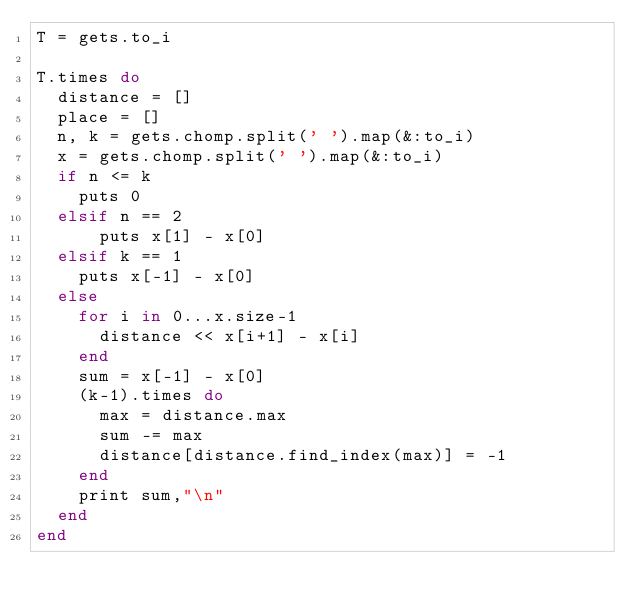<code> <loc_0><loc_0><loc_500><loc_500><_Ruby_>T = gets.to_i

T.times do
  distance = []
  place = []
  n, k = gets.chomp.split(' ').map(&:to_i) 
  x = gets.chomp.split(' ').map(&:to_i)
  if n <= k
    puts 0
  elsif n == 2
      puts x[1] - x[0]
  elsif k == 1
    puts x[-1] - x[0]
  else
    for i in 0...x.size-1
      distance << x[i+1] - x[i]
    end
    sum = x[-1] - x[0]
    (k-1).times do
      max = distance.max  
      sum -= max
      distance[distance.find_index(max)] = -1
    end
    print sum,"\n" 
  end
end</code> 